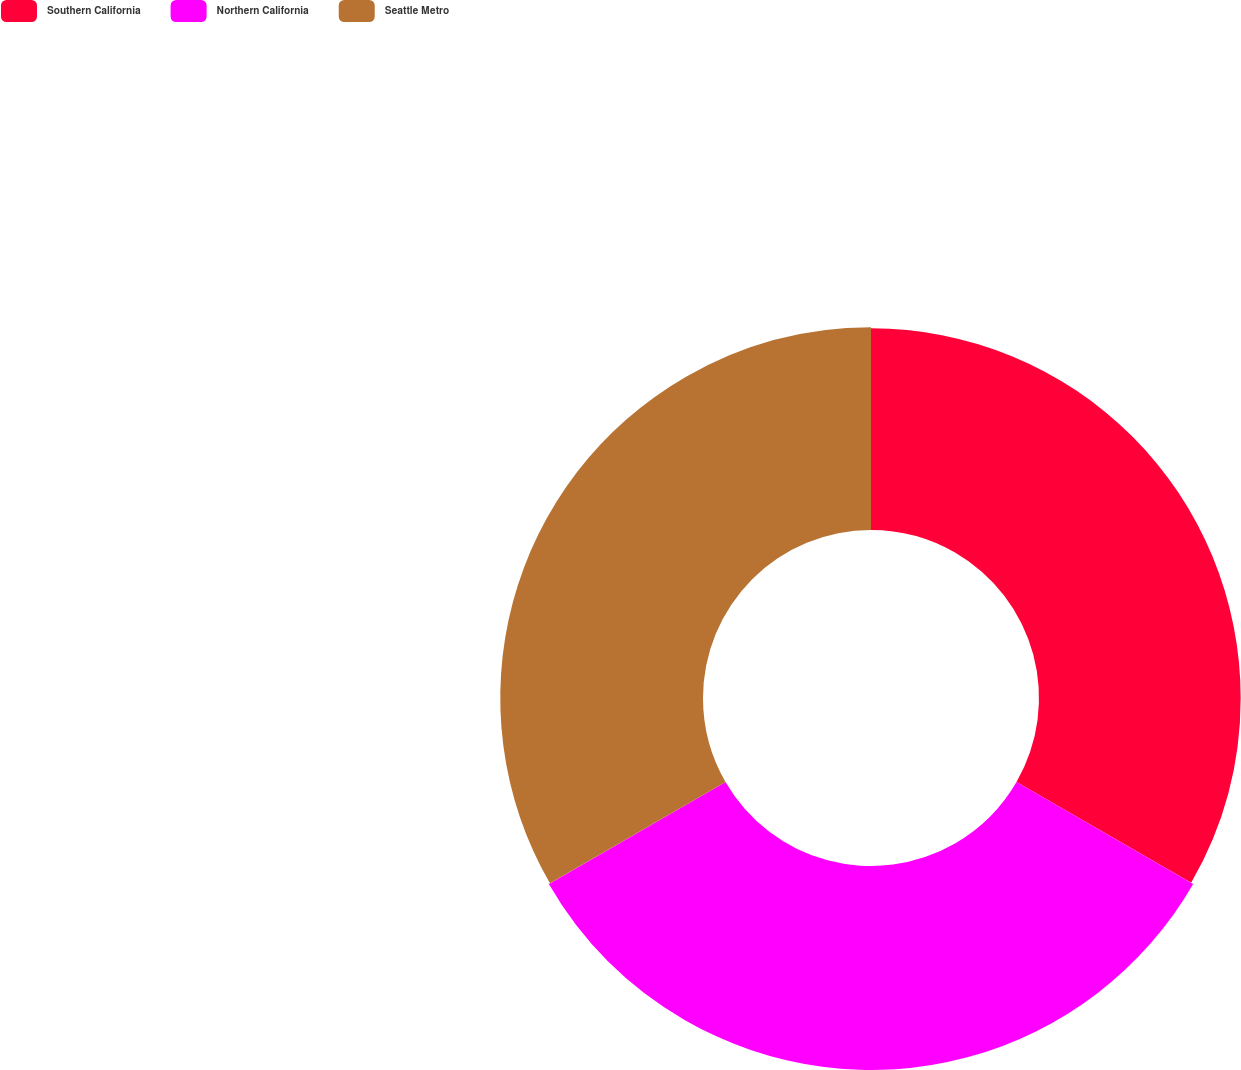<chart> <loc_0><loc_0><loc_500><loc_500><pie_chart><fcel>Southern California<fcel>Northern California<fcel>Seattle Metro<nl><fcel>33.15%<fcel>33.53%<fcel>33.32%<nl></chart> 